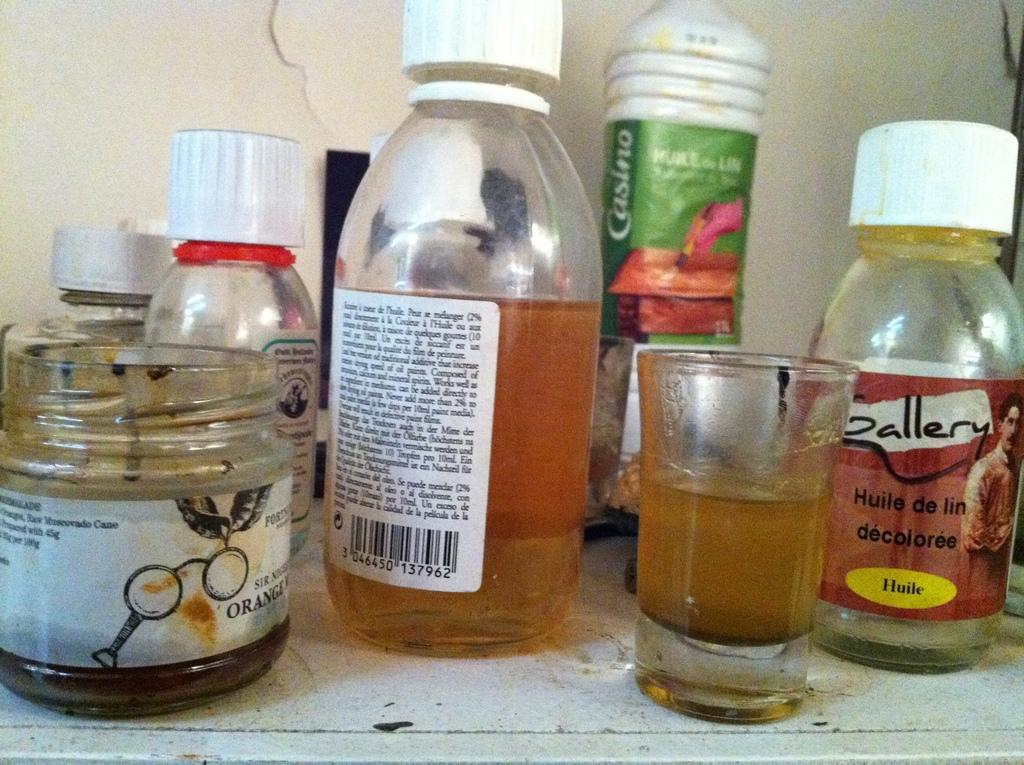<image>
Render a clear and concise summary of the photo. Some craft supplies, including an empty bottle labelled 'Huile de lin décolorée'. 